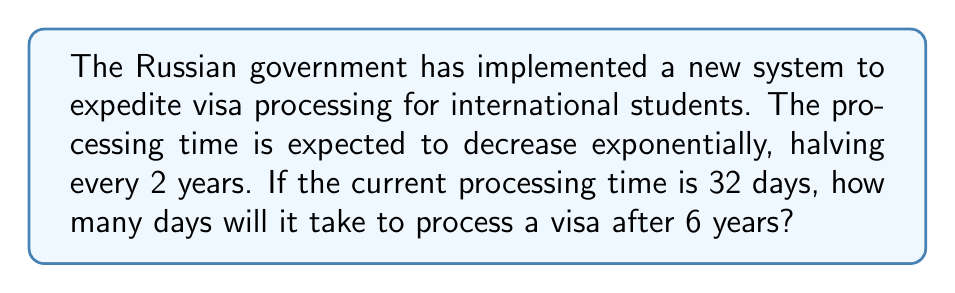Solve this math problem. Let's approach this step-by-step:

1) We're dealing with an exponential decay situation, where the time is halving every 2 years.

2) The general form of exponential decay is:

   $$A = A_0 \cdot (1/2)^{t/h}$$

   Where:
   $A$ is the final amount
   $A_0$ is the initial amount
   $t$ is the time elapsed
   $h$ is the half-life (time it takes to halve)

3) In this case:
   $A_0 = 32$ days (initial processing time)
   $t = 6$ years (time elapsed)
   $h = 2$ years (time it takes to halve)

4) Plugging these into our formula:

   $$A = 32 \cdot (1/2)^{6/2}$$

5) Simplify the exponent:
   
   $$A = 32 \cdot (1/2)^3$$

6) Calculate $(1/2)^3$:
   
   $$A = 32 \cdot \frac{1}{8}$$

7) Multiply:
   
   $$A = 4$$

Therefore, after 6 years, the visa processing time will be 4 days.
Answer: 4 days 